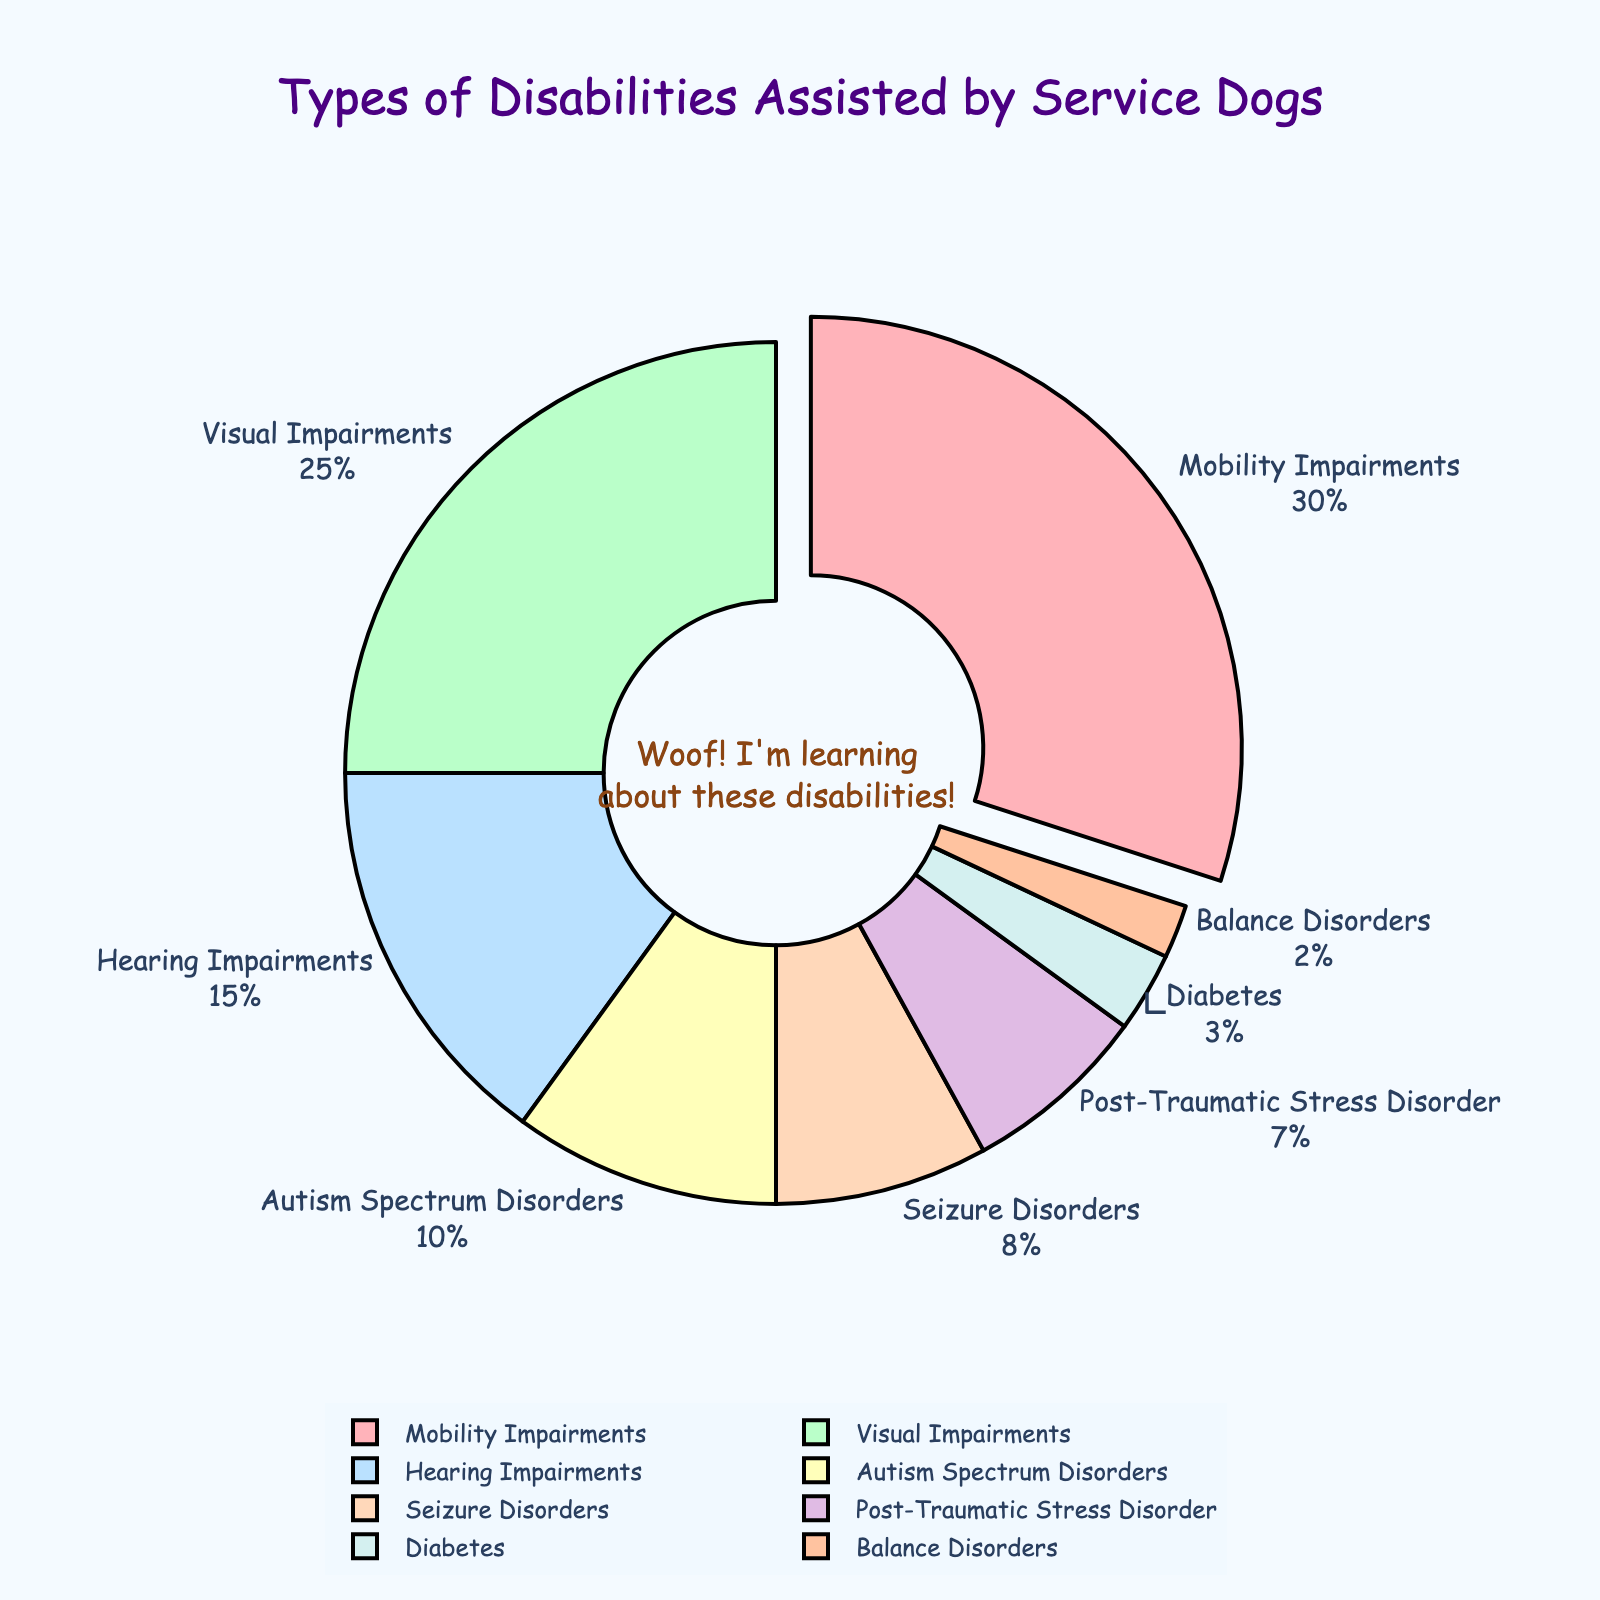What is the most common type of disability assisted by service dogs? The largest segment on the pie chart, which is also pulled out slightly, represents Mobility Impairments. This indicates that Mobility Impairments have the highest percentage.
Answer: Mobility Impairments Which type of disability is assisted by service dogs more: Hearing Impairments or Autism Spectrum Disorders? By comparing the sizes of the segments labeled "Hearing Impairments" and "Autism Spectrum Disorders," we can see that the segment for Hearing Impairments is bigger. This means that they assist Hearing Impairments more.
Answer: Hearing Impairments What percentage of service dogs assist with Seizure Disorders and Diabetes combined? According to the pie chart, Seizure Disorders have 8% and Diabetes has 3%. Summing these percentages gives 8 + 3 = 11%.
Answer: 11% Are Visual Impairments assisted by service dogs more or less than Post-Traumatic Stress Disorder (PTSD)? The segment for Visual Impairments is noticeably larger than the segment for PTSD. This indicates that Visual Impairments are assisted more.
Answer: More If you combine the assistance percentages for balance and diabetes, is the result greater than or less than the assistance percentage for autism spectrum disorders? Balance Disorders have 2% and Diabetes has 3%. Adding these together gives 2 + 3 = 5%, which is less than the 10% for Autism Spectrum Disorders.
Answer: Less What is the difference in percentage between Mobility Impairments and Hearing Impairments? Mobility Impairments have 30% and Hearing Impairments have 15%. Subtracting these gives 30 - 15 = 15%.
Answer: 15% Which disability type is assisted by service dogs the least? The smallest segment on the pie chart represents Balance Disorders, indicating they have the lowest percentage.
Answer: Balance Disorders How much greater in percentage is the assistance for Visual Impairments compared to Diabetes? Visual Impairments have 25% and Diabetes has 3%. The difference is 25 - 3 = 22%.
Answer: 22% 